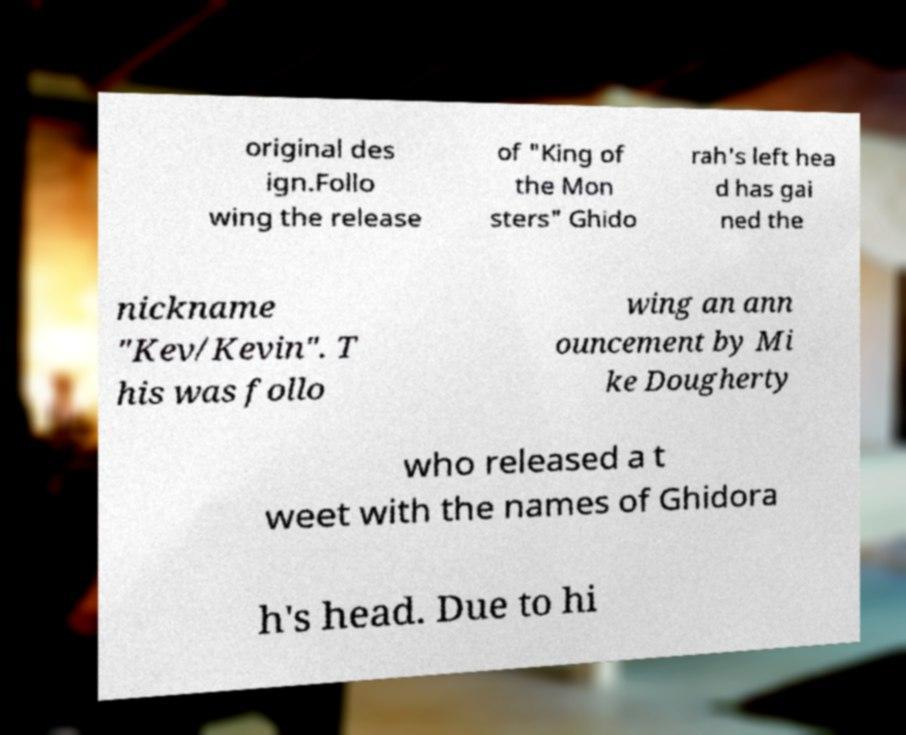What messages or text are displayed in this image? I need them in a readable, typed format. original des ign.Follo wing the release of "King of the Mon sters" Ghido rah's left hea d has gai ned the nickname "Kev/Kevin". T his was follo wing an ann ouncement by Mi ke Dougherty who released a t weet with the names of Ghidora h's head. Due to hi 